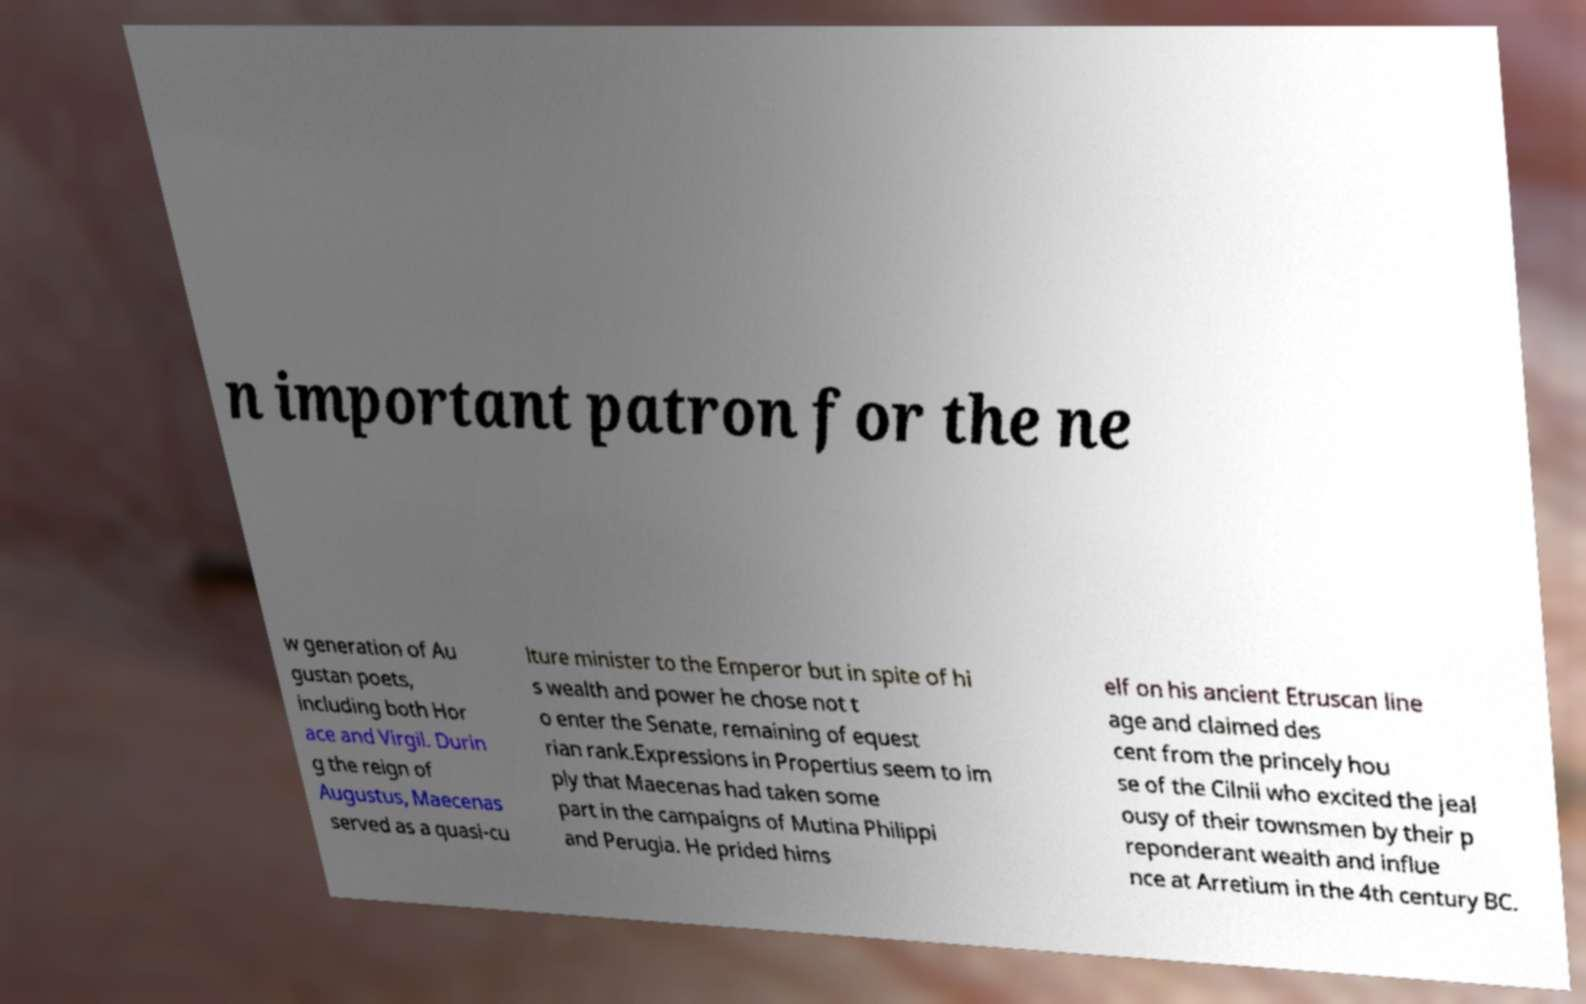Can you read and provide the text displayed in the image?This photo seems to have some interesting text. Can you extract and type it out for me? n important patron for the ne w generation of Au gustan poets, including both Hor ace and Virgil. Durin g the reign of Augustus, Maecenas served as a quasi-cu lture minister to the Emperor but in spite of hi s wealth and power he chose not t o enter the Senate, remaining of equest rian rank.Expressions in Propertius seem to im ply that Maecenas had taken some part in the campaigns of Mutina Philippi and Perugia. He prided hims elf on his ancient Etruscan line age and claimed des cent from the princely hou se of the Cilnii who excited the jeal ousy of their townsmen by their p reponderant wealth and influe nce at Arretium in the 4th century BC. 